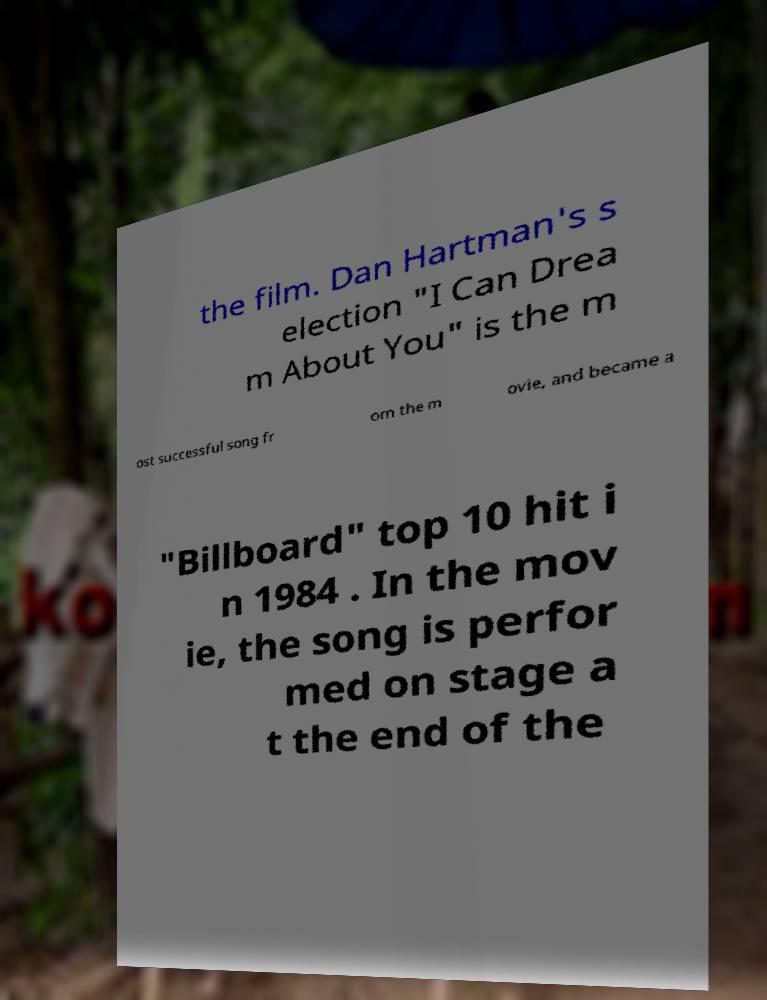Can you read and provide the text displayed in the image?This photo seems to have some interesting text. Can you extract and type it out for me? the film. Dan Hartman's s election "I Can Drea m About You" is the m ost successful song fr om the m ovie, and became a "Billboard" top 10 hit i n 1984 . In the mov ie, the song is perfor med on stage a t the end of the 